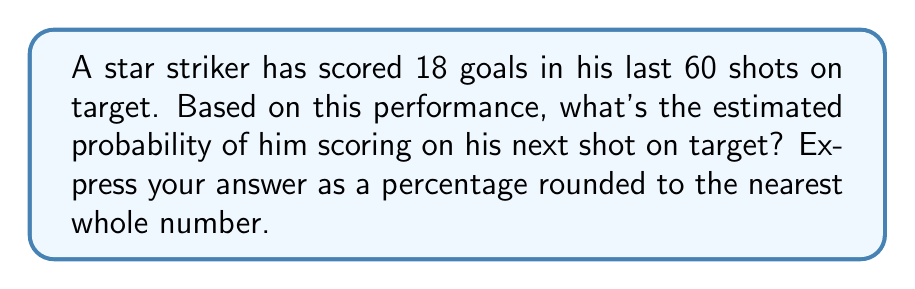Give your solution to this math problem. To estimate the probability of scoring a goal based on past performance statistics, we'll follow these steps:

1. Identify the relevant data:
   - Total shots on target: 60
   - Goals scored: 18

2. Calculate the probability:
   $$ P(\text{scoring}) = \frac{\text{Number of successful outcomes}}{\text{Total number of attempts}} $$
   
   $$ P(\text{scoring}) = \frac{18}{60} $$

3. Simplify the fraction:
   $$ P(\text{scoring}) = \frac{3}{10} = 0.3 $$

4. Convert to a percentage:
   $$ 0.3 \times 100\% = 30\% $$

5. The question asks for the nearest whole number, so 30% is our final answer.

This means that based on the striker's past performance, there's a 30% chance he'll score on his next shot on target.
Answer: 30% 